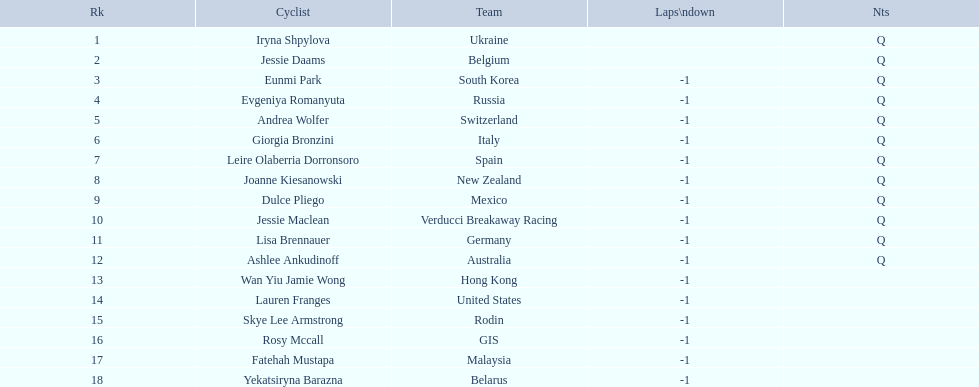Who are all the cyclists? Iryna Shpylova, Jessie Daams, Eunmi Park, Evgeniya Romanyuta, Andrea Wolfer, Giorgia Bronzini, Leire Olaberria Dorronsoro, Joanne Kiesanowski, Dulce Pliego, Jessie Maclean, Lisa Brennauer, Ashlee Ankudinoff, Wan Yiu Jamie Wong, Lauren Franges, Skye Lee Armstrong, Rosy Mccall, Fatehah Mustapa, Yekatsiryna Barazna. What were their ranks? 1, 2, 3, 4, 5, 6, 7, 8, 9, 10, 11, 12, 13, 14, 15, 16, 17, 18. Who was ranked highest? Iryna Shpylova. 